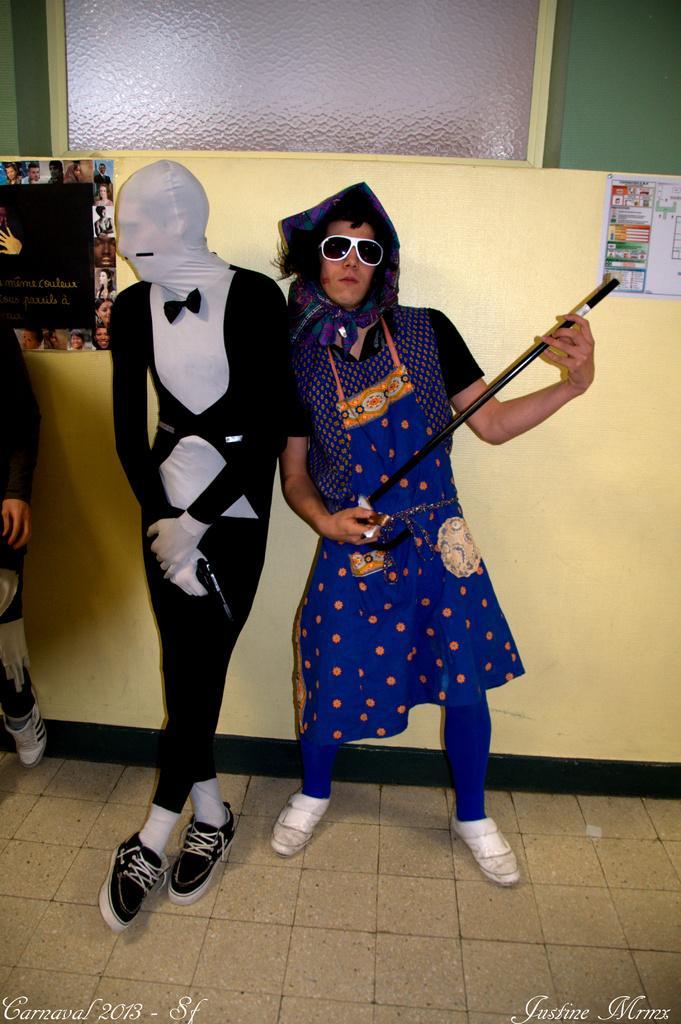Please provide a concise description of this image. In the center we can see the two persons holding some objects and standing on the ground. In the background we can see the posts attached to the wall and we can see the text and some pictures on the posters. On the left corner there is a person seems to be standing. In the background there is a green color wall and the window. At the bottom there is a text on the image. 